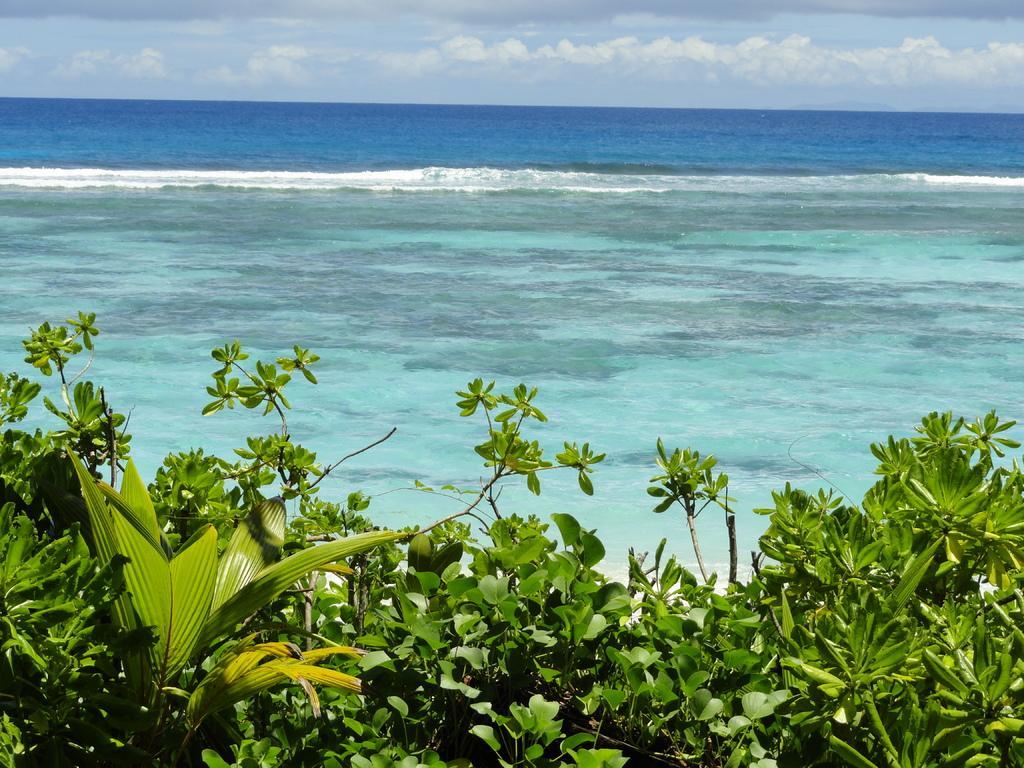In one or two sentences, can you explain what this image depicts? These are the green color trees, this is water. At the top it's a sky. 